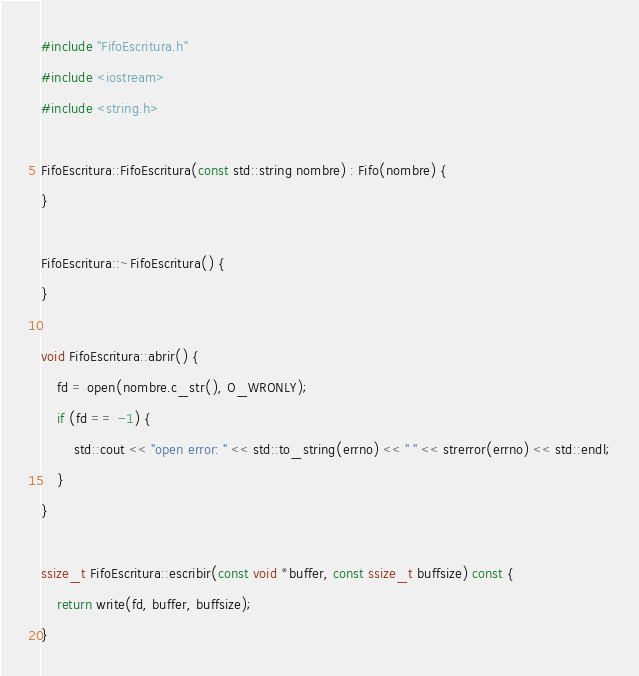Convert code to text. <code><loc_0><loc_0><loc_500><loc_500><_C++_>#include "FifoEscritura.h"
#include <iostream>
#include <string.h>

FifoEscritura::FifoEscritura(const std::string nombre) : Fifo(nombre) {
}

FifoEscritura::~FifoEscritura() {
}

void FifoEscritura::abrir() {
	fd = open(nombre.c_str(), O_WRONLY);
	if (fd == -1) {
		std::cout << "open error: " << std::to_string(errno) << " " << strerror(errno) << std::endl;
	}
}

ssize_t FifoEscritura::escribir(const void *buffer, const ssize_t buffsize) const {
	return write(fd, buffer, buffsize);
}
</code> 